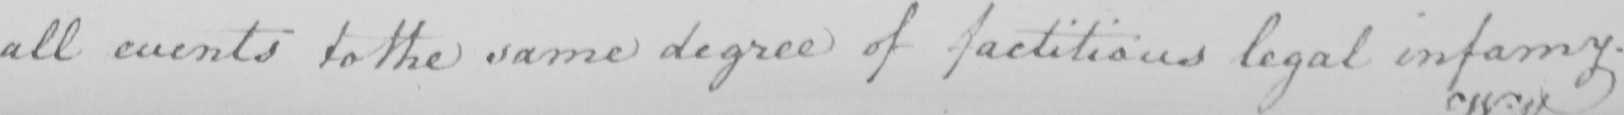Transcribe the text shown in this historical manuscript line. all events to the same degree of factitious legal infamy . 